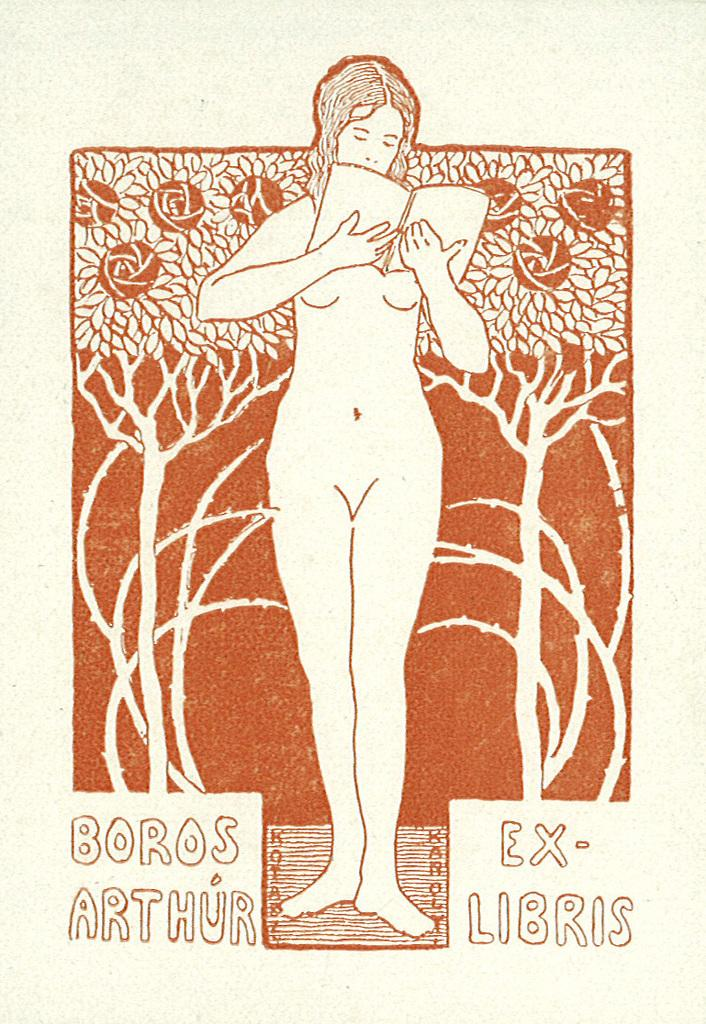What type of image is shown in the picture? The image is a drawing. What is the subject of the drawing? The drawing depicts a woman. How does the woman increase her speed while skating in the drawing? The drawing does not depict the woman skating, nor does it show any increase in speed. 